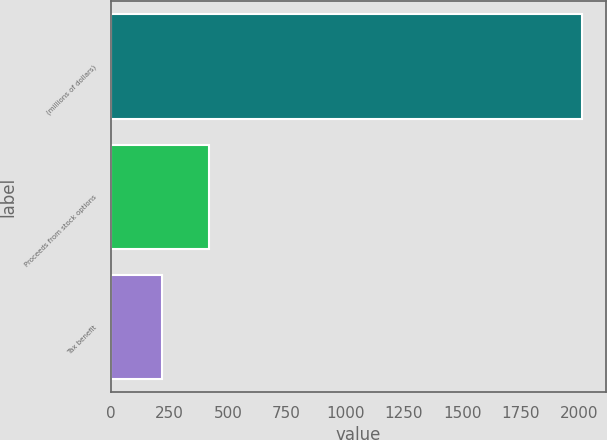Convert chart to OTSL. <chart><loc_0><loc_0><loc_500><loc_500><bar_chart><fcel>(millions of dollars)<fcel>Proceeds from stock options<fcel>Tax benefit<nl><fcel>2012<fcel>419.12<fcel>220.01<nl></chart> 